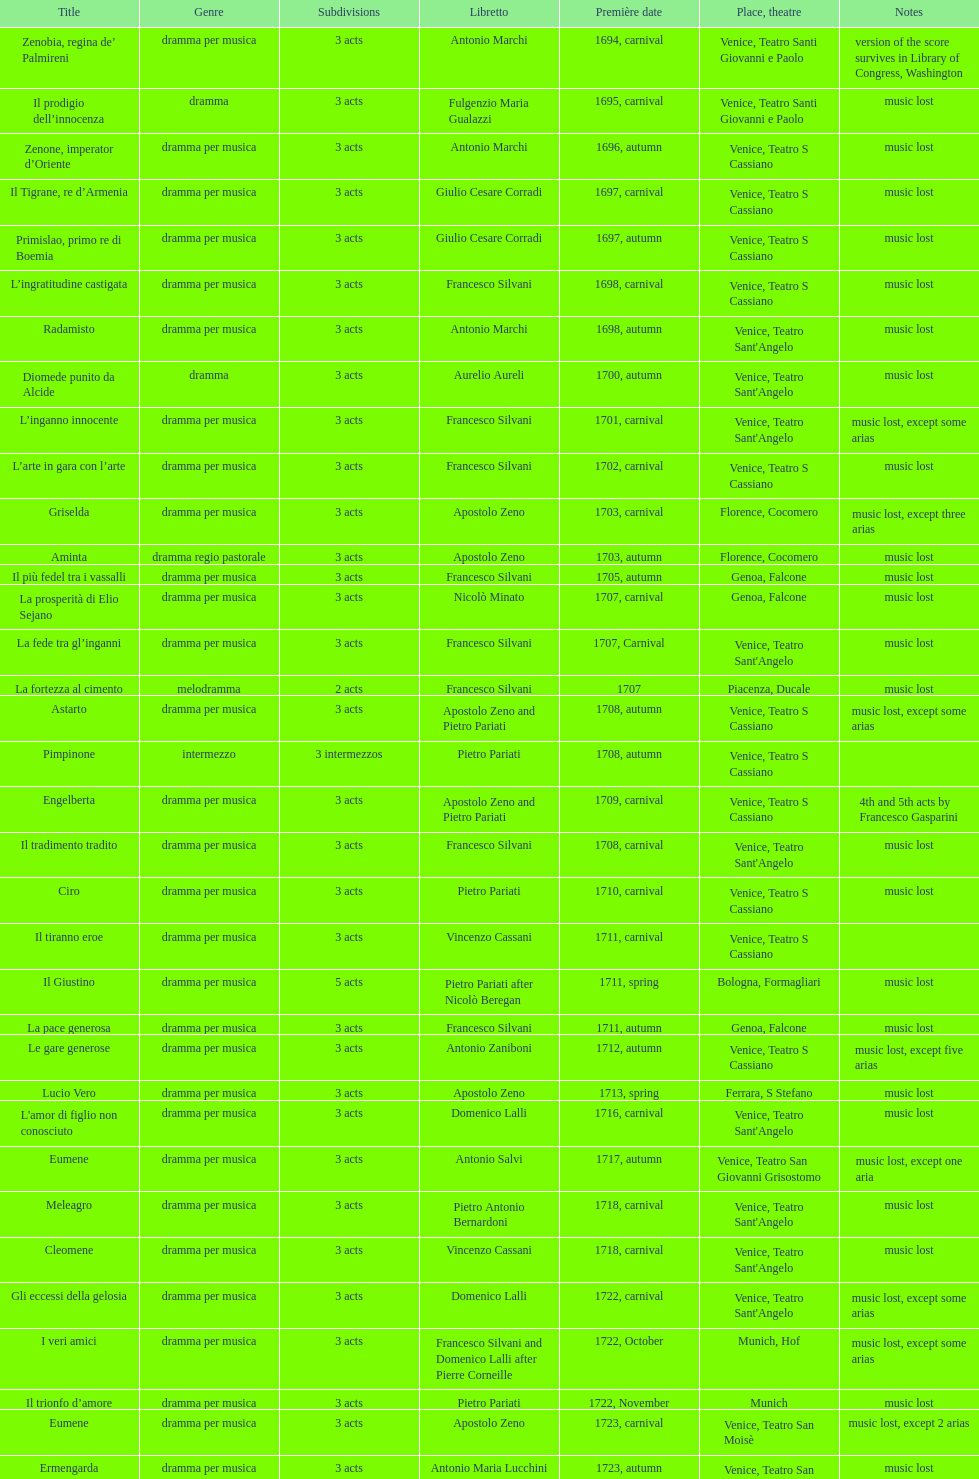How many operas on this list possess a minimum of 3 acts? 51. 